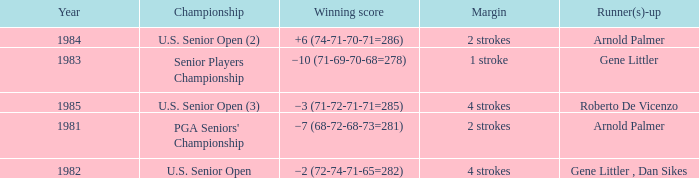What margin was in after 1981, and was Roberto De Vicenzo runner-up? 4 strokes. 